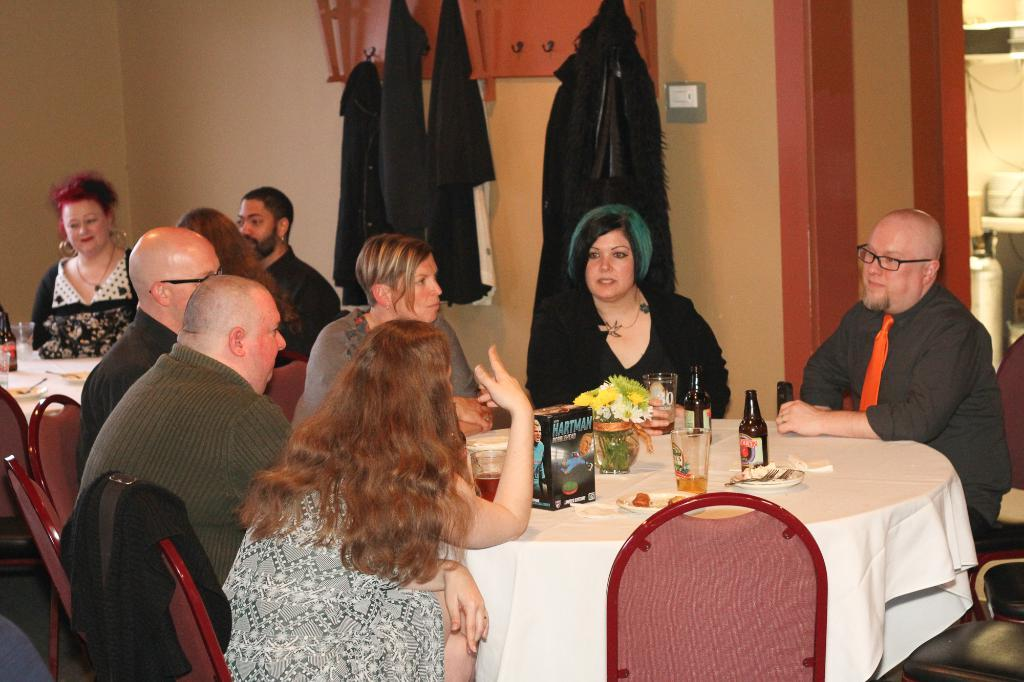How many people are in the image? There is a group of people in the image. What are the people doing in the image? The people are sitting on chairs. Where are the chairs located in relation to the table? The chairs are in front of a table. What is on the table in the image? There is a box on the table, along with other objects. What type of cheese is being served by the sister in the image? There is no cheese or sister present in the image. How many tomatoes are on the table in the image? There is no mention of tomatoes in the image; only a box and other unspecified objects are present on the table. 